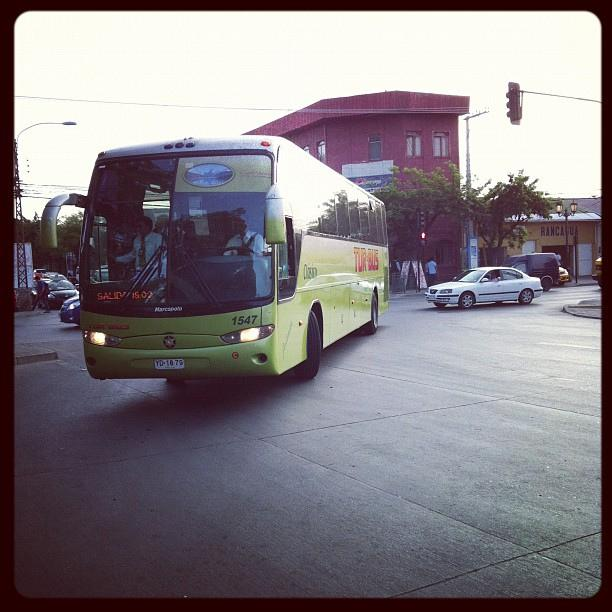What make of vehicle is following the bus? volvo 